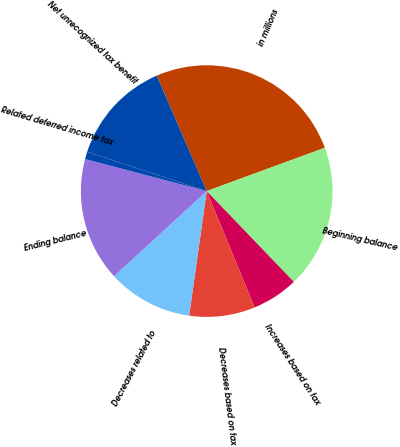<chart> <loc_0><loc_0><loc_500><loc_500><pie_chart><fcel>in millions<fcel>Beginning balance<fcel>Increases based on tax<fcel>Decreases based on tax<fcel>Decreases related to<fcel>Ending balance<fcel>Related deferred income tax<fcel>Net unrecognized tax benefit<nl><fcel>25.91%<fcel>18.42%<fcel>5.95%<fcel>8.45%<fcel>10.94%<fcel>15.93%<fcel>0.96%<fcel>13.44%<nl></chart> 